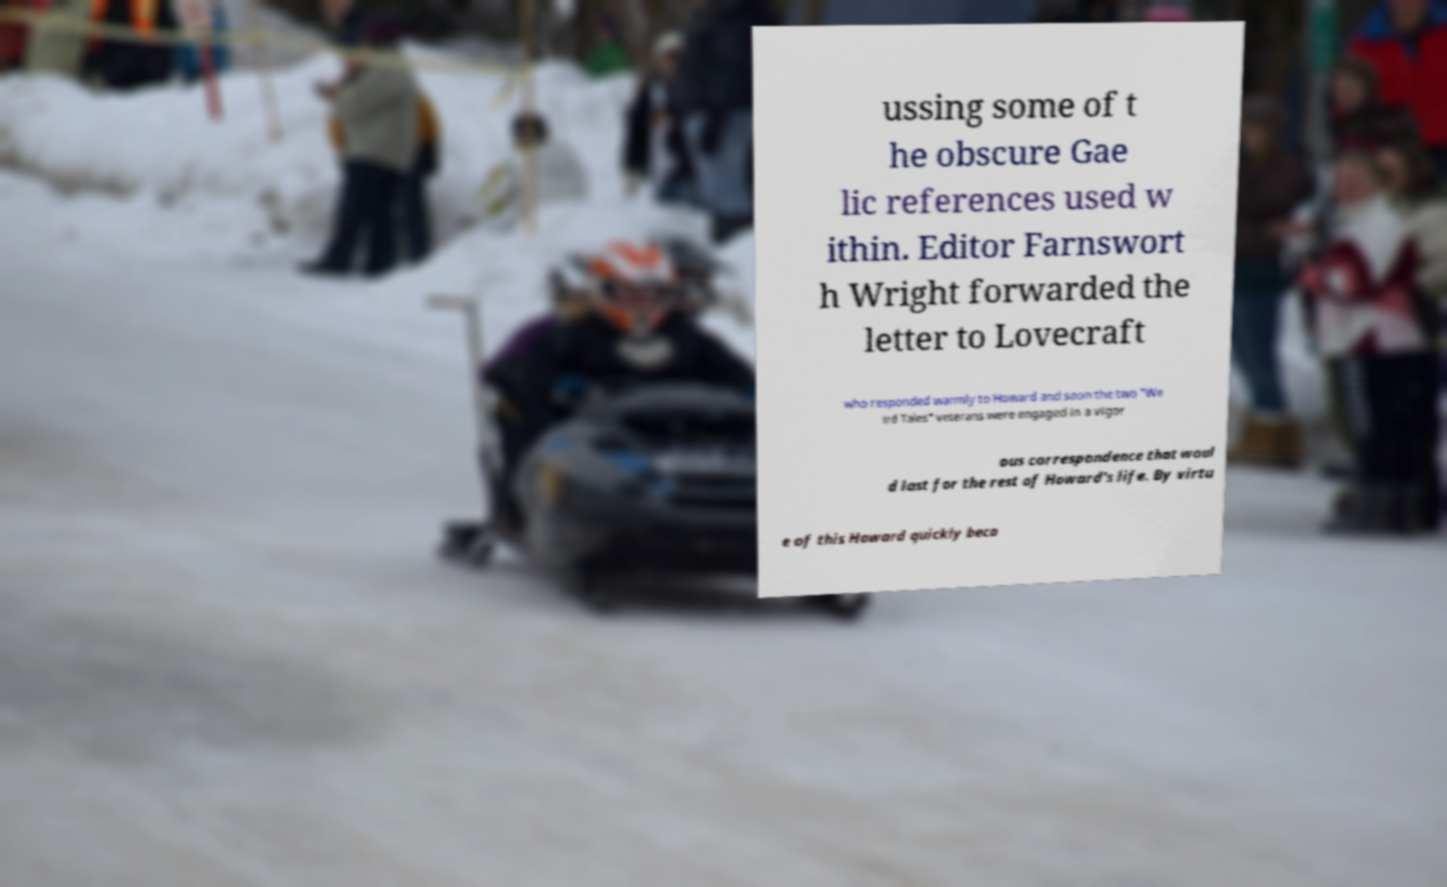Could you extract and type out the text from this image? ussing some of t he obscure Gae lic references used w ithin. Editor Farnswort h Wright forwarded the letter to Lovecraft who responded warmly to Howard and soon the two "We ird Tales" veterans were engaged in a vigor ous correspondence that woul d last for the rest of Howard's life. By virtu e of this Howard quickly beca 